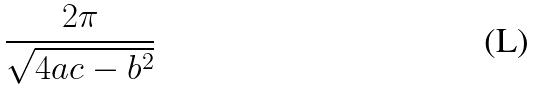<formula> <loc_0><loc_0><loc_500><loc_500>\frac { 2 \pi } { \sqrt { 4 a c - b ^ { 2 } } }</formula> 